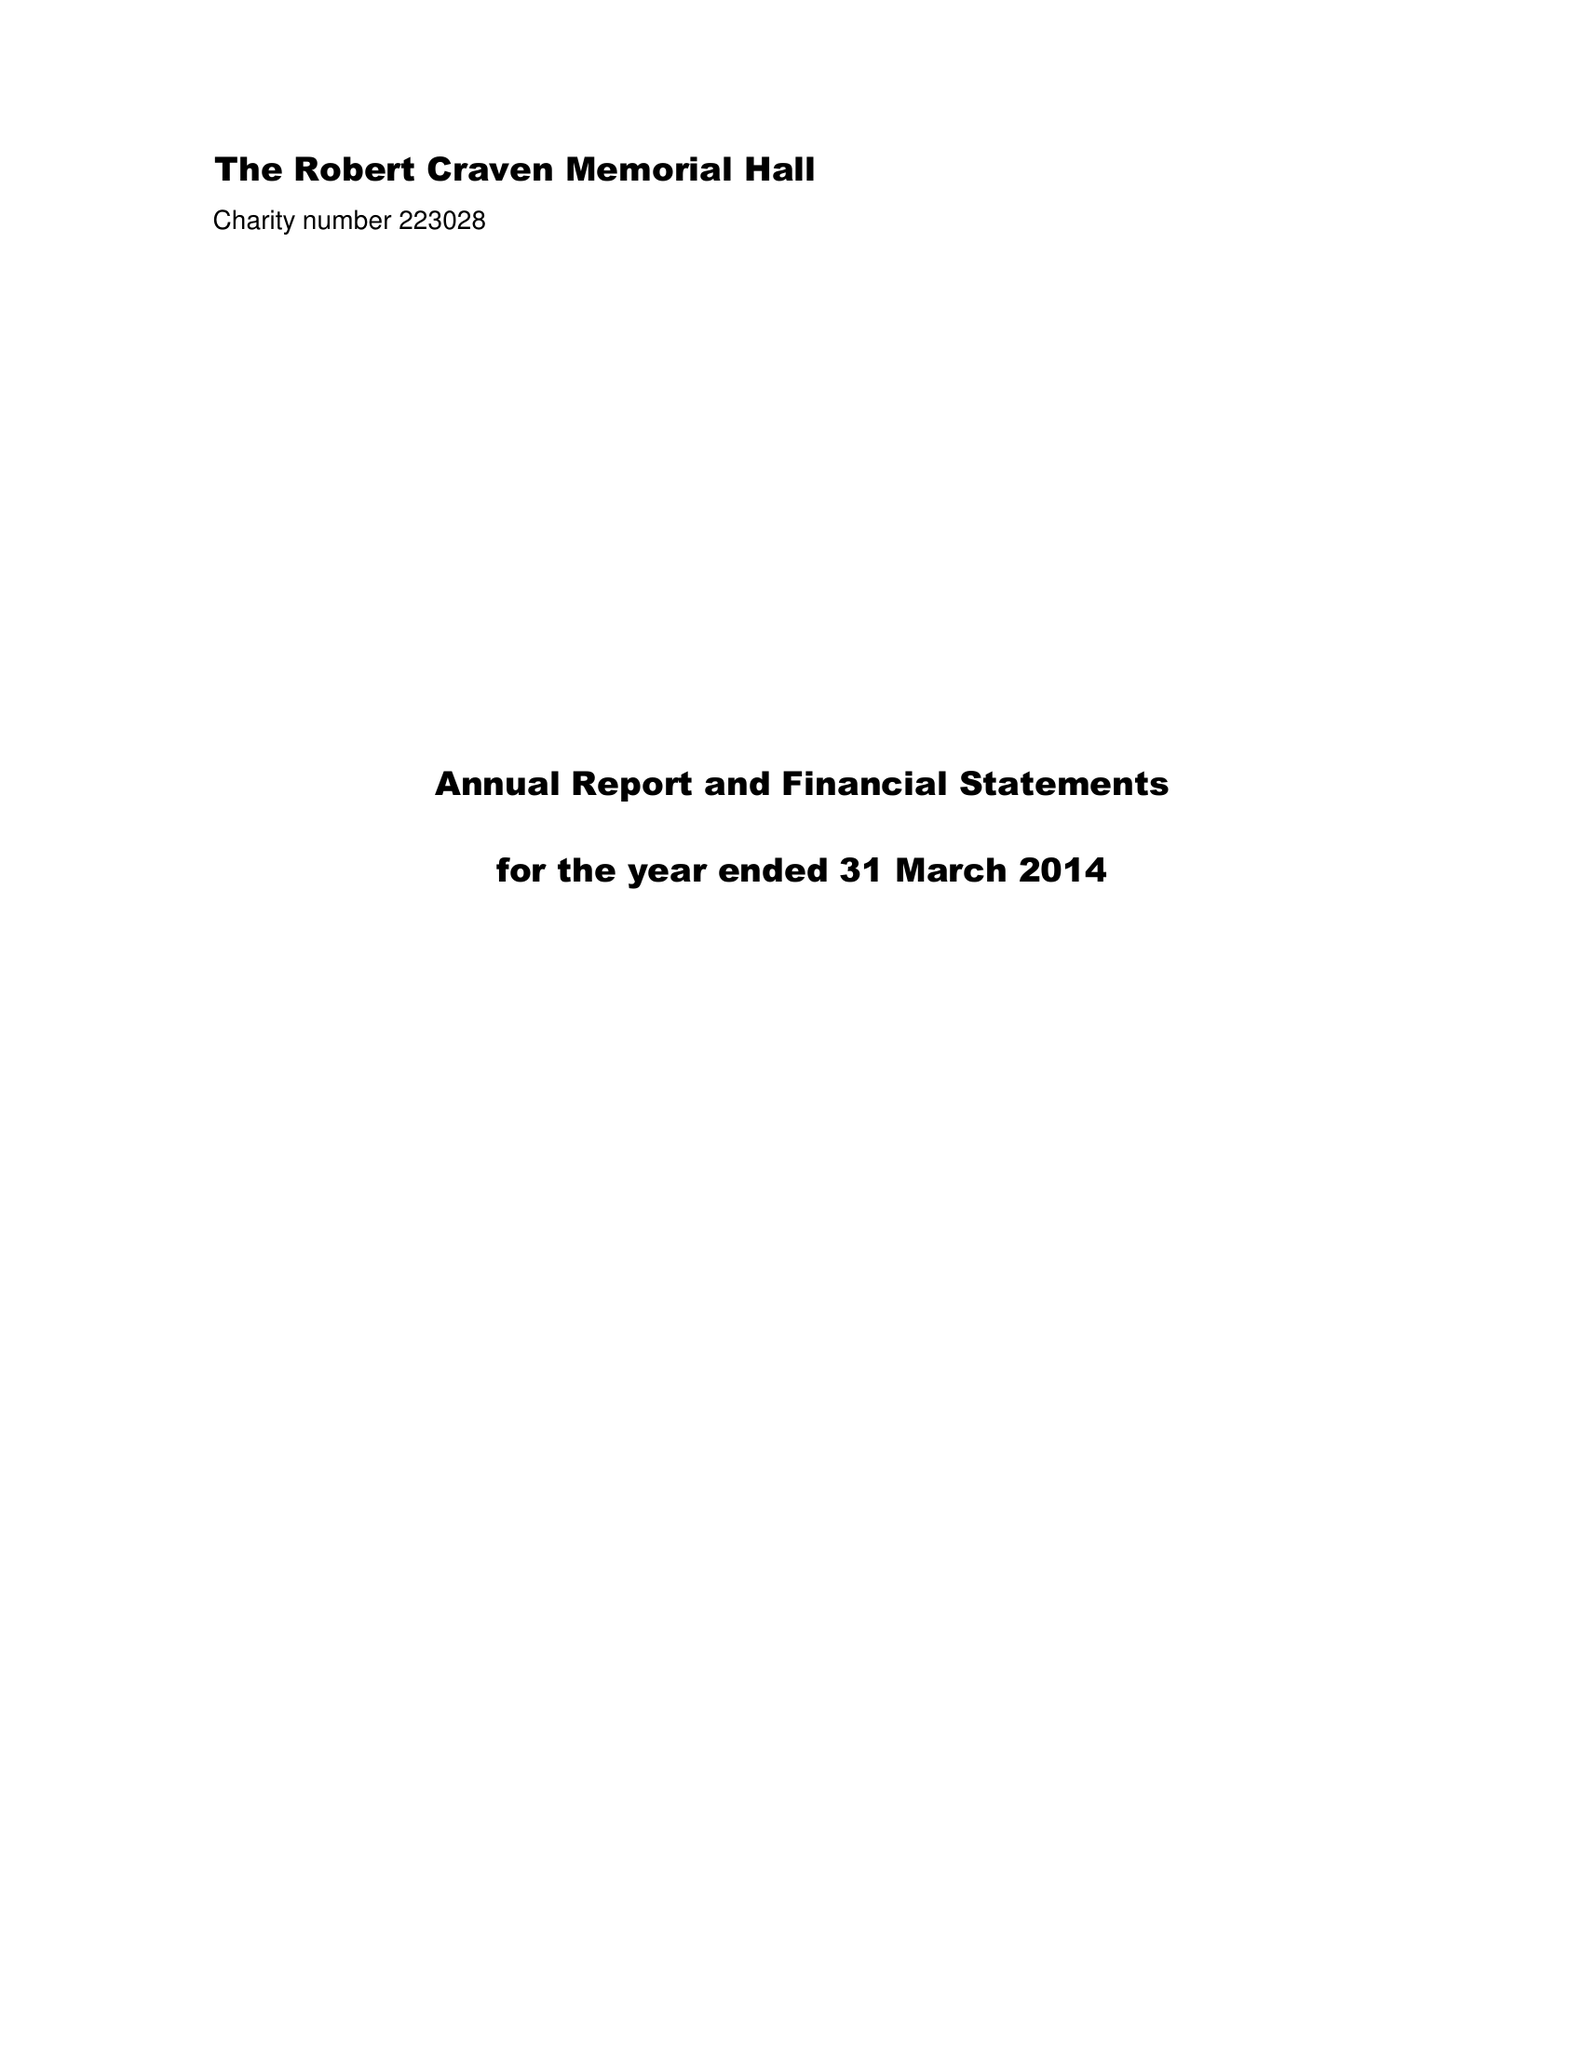What is the value for the address__street_line?
Answer the question using a single word or phrase. MOOR ROAD 